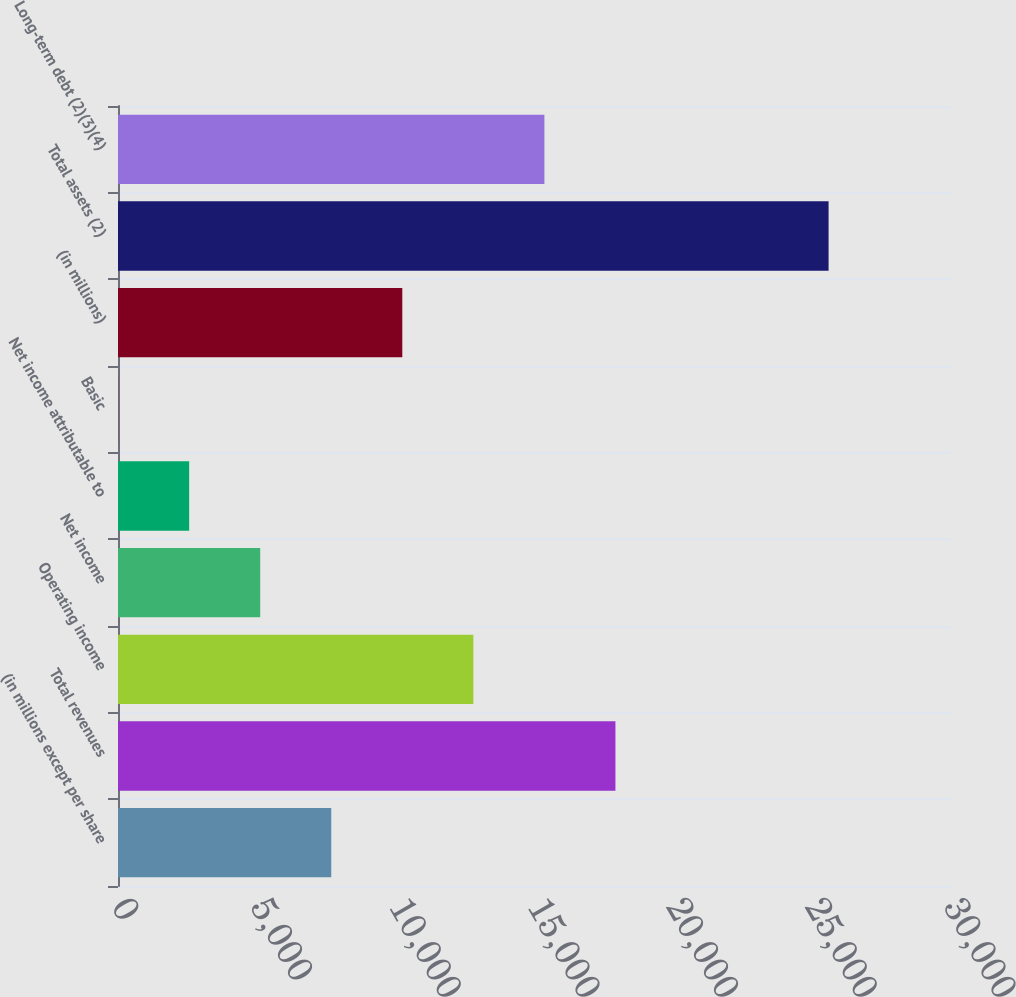Convert chart. <chart><loc_0><loc_0><loc_500><loc_500><bar_chart><fcel>(in millions except per share<fcel>Total revenues<fcel>Operating income<fcel>Net income<fcel>Net income attributable to<fcel>Basic<fcel>(in millions)<fcel>Total assets (2)<fcel>Long-term debt (2)(3)(4)<nl><fcel>7689.58<fcel>17936.7<fcel>12813.1<fcel>5127.81<fcel>2566.04<fcel>4.27<fcel>10251.4<fcel>25622<fcel>15374.9<nl></chart> 